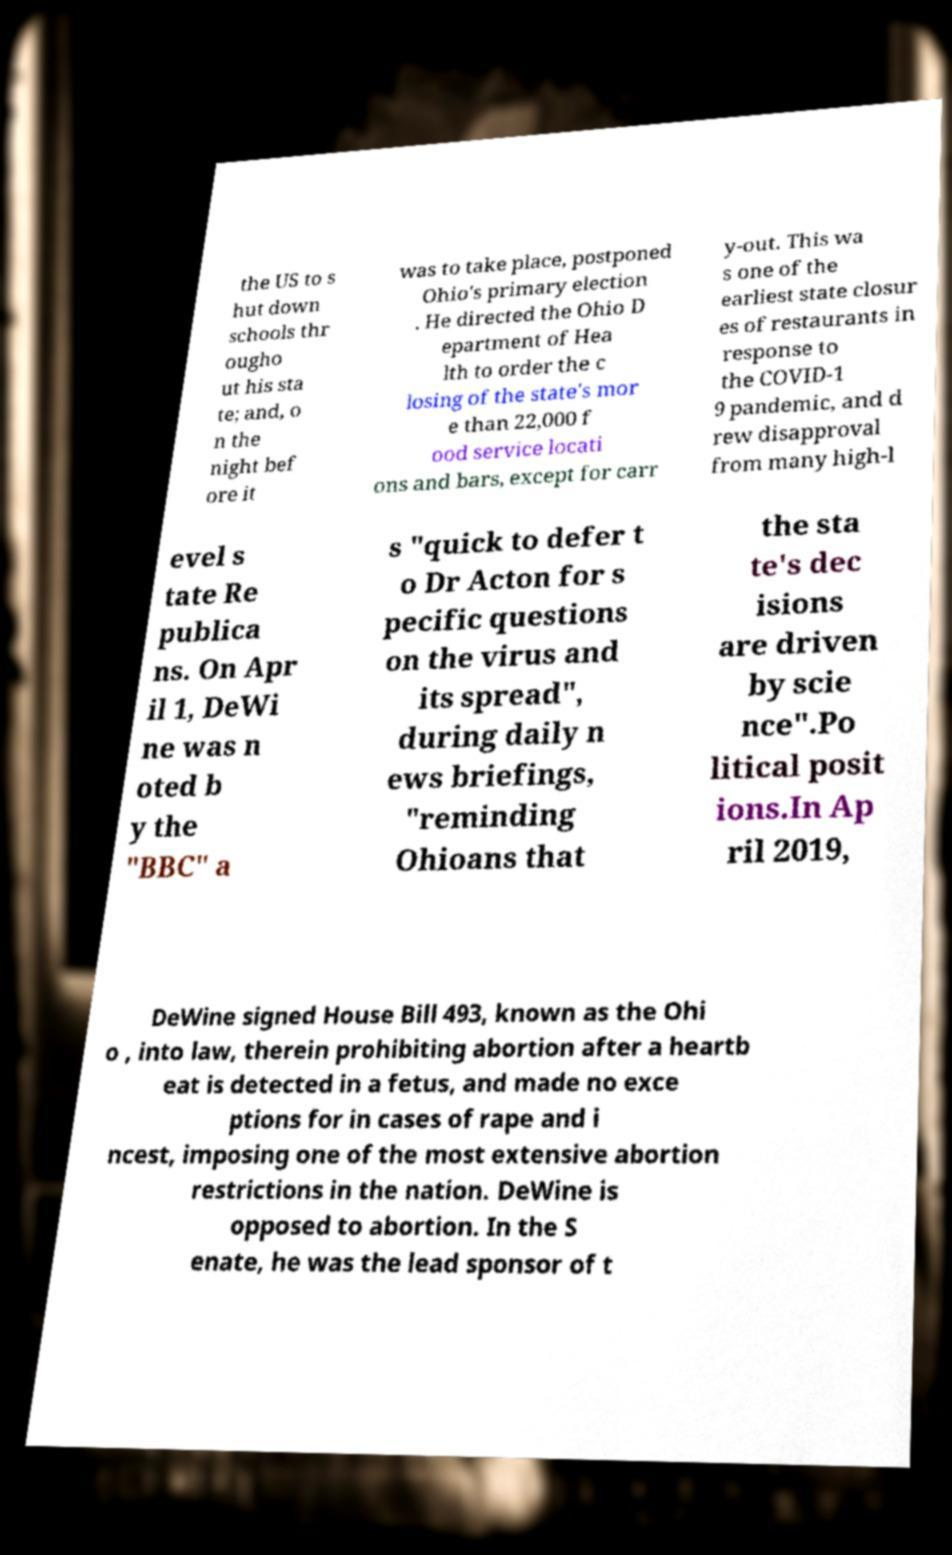Can you read and provide the text displayed in the image?This photo seems to have some interesting text. Can you extract and type it out for me? the US to s hut down schools thr ougho ut his sta te; and, o n the night bef ore it was to take place, postponed Ohio's primary election . He directed the Ohio D epartment of Hea lth to order the c losing of the state's mor e than 22,000 f ood service locati ons and bars, except for carr y-out. This wa s one of the earliest state closur es of restaurants in response to the COVID-1 9 pandemic, and d rew disapproval from many high-l evel s tate Re publica ns. On Apr il 1, DeWi ne was n oted b y the "BBC" a s "quick to defer t o Dr Acton for s pecific questions on the virus and its spread", during daily n ews briefings, "reminding Ohioans that the sta te's dec isions are driven by scie nce".Po litical posit ions.In Ap ril 2019, DeWine signed House Bill 493, known as the Ohi o , into law, therein prohibiting abortion after a heartb eat is detected in a fetus, and made no exce ptions for in cases of rape and i ncest, imposing one of the most extensive abortion restrictions in the nation. DeWine is opposed to abortion. In the S enate, he was the lead sponsor of t 